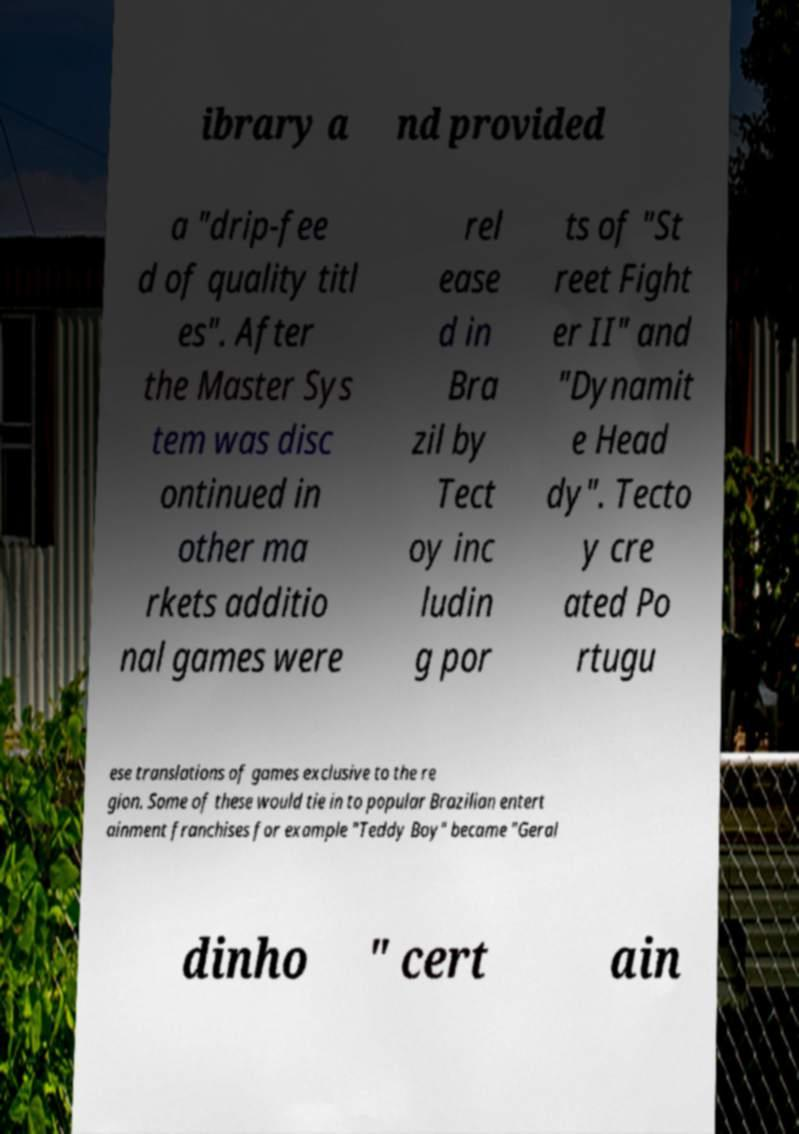Please identify and transcribe the text found in this image. ibrary a nd provided a "drip-fee d of quality titl es". After the Master Sys tem was disc ontinued in other ma rkets additio nal games were rel ease d in Bra zil by Tect oy inc ludin g por ts of "St reet Fight er II" and "Dynamit e Head dy". Tecto y cre ated Po rtugu ese translations of games exclusive to the re gion. Some of these would tie in to popular Brazilian entert ainment franchises for example "Teddy Boy" became "Geral dinho " cert ain 